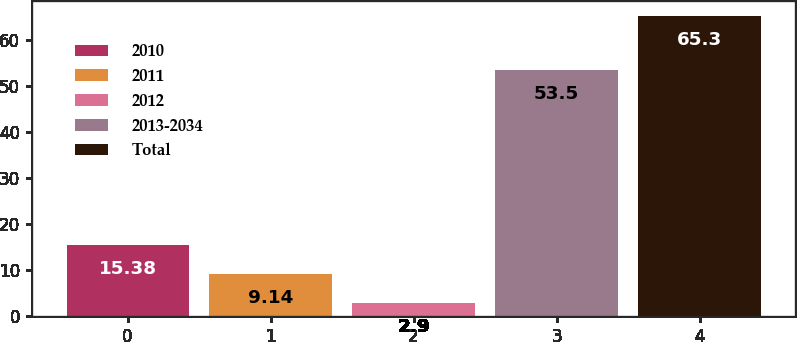<chart> <loc_0><loc_0><loc_500><loc_500><bar_chart><fcel>2010<fcel>2011<fcel>2012<fcel>2013-2034<fcel>Total<nl><fcel>15.38<fcel>9.14<fcel>2.9<fcel>53.5<fcel>65.3<nl></chart> 